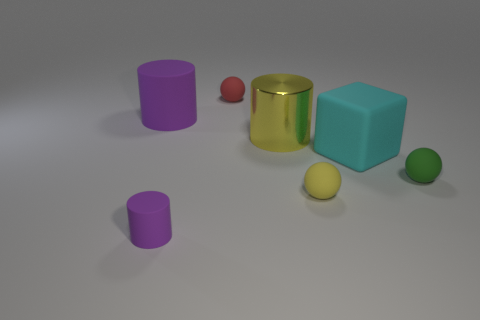How many things are either tiny objects behind the tiny purple cylinder or big matte things behind the big metal cylinder?
Provide a succinct answer. 4. Is the number of purple cylinders right of the cyan rubber thing less than the number of yellow things?
Keep it short and to the point. Yes. Is the big cyan thing made of the same material as the purple thing behind the yellow metallic thing?
Your answer should be very brief. Yes. What is the large cyan object made of?
Keep it short and to the point. Rubber. What is the big cylinder behind the cylinder that is right of the small rubber object that is behind the small green matte object made of?
Your response must be concise. Rubber. Is the color of the big metal object the same as the rubber ball that is behind the green rubber object?
Offer a very short reply. No. Is there any other thing that is the same shape as the small yellow thing?
Keep it short and to the point. Yes. What color is the rubber cylinder on the left side of the purple matte thing in front of the big matte cylinder?
Your answer should be very brief. Purple. What number of red cubes are there?
Your answer should be very brief. 0. How many rubber objects are purple cylinders or blocks?
Provide a succinct answer. 3. 